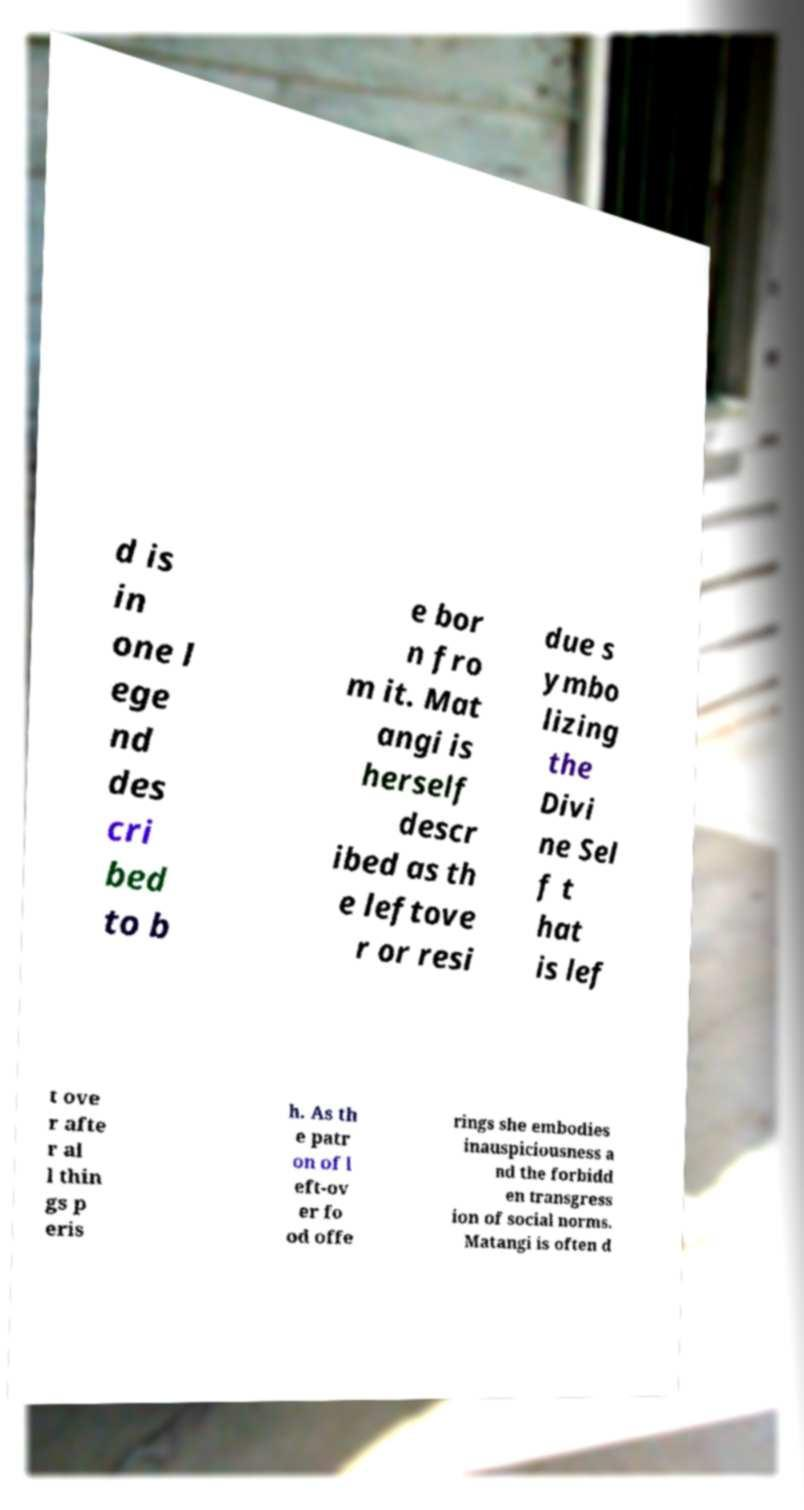Can you accurately transcribe the text from the provided image for me? d is in one l ege nd des cri bed to b e bor n fro m it. Mat angi is herself descr ibed as th e leftove r or resi due s ymbo lizing the Divi ne Sel f t hat is lef t ove r afte r al l thin gs p eris h. As th e patr on of l eft-ov er fo od offe rings she embodies inauspiciousness a nd the forbidd en transgress ion of social norms. Matangi is often d 